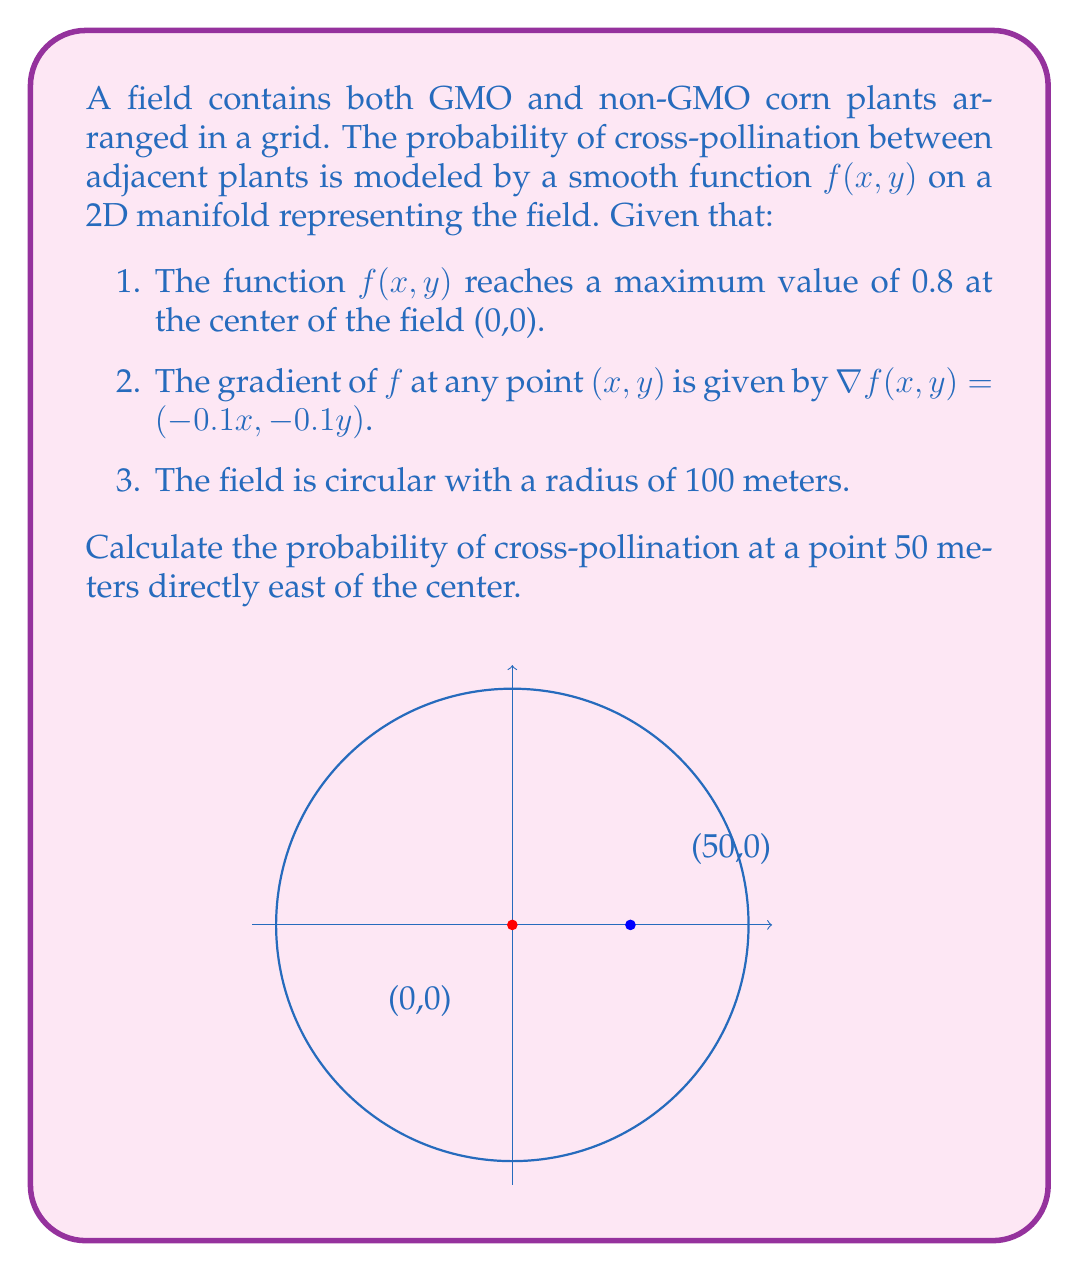Give your solution to this math problem. To solve this problem, we'll use the properties of the gradient on a manifold:

1) First, we know that the gradient points in the direction of steepest increase and its magnitude gives the rate of increase in that direction.

2) Given $\nabla f(x,y) = (-0.1x, -0.1y)$, we can see that the gradient always points towards the origin (0,0), which is consistent with the maximum being at the center.

3) To find $f(50,0)$, we need to integrate the gradient from (0,0) to (50,0):

   $$\int_0^{50} \nabla f \cdot d\mathbf{r} = \int_0^{50} (-0.1x, 0) \cdot (1,0) dx = \int_0^{50} -0.1x dx$$

4) Evaluating this integral:

   $$\int_0^{50} -0.1x dx = -0.1 \cdot \frac{x^2}{2} \bigg|_0^{50} = -0.1 \cdot \frac{50^2}{2} = -125$$

5) This gives us the change in $f$ from (0,0) to (50,0). Since $f(0,0) = 0.8$, we have:

   $$f(50,0) = 0.8 - 125 = 0.675$$

Therefore, the probability of cross-pollination at the point 50 meters east of the center is 0.675 or 67.5%.
Answer: 0.675 